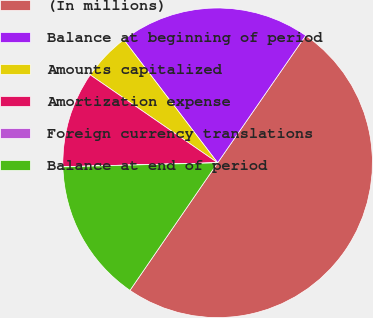Convert chart. <chart><loc_0><loc_0><loc_500><loc_500><pie_chart><fcel>(In millions)<fcel>Balance at beginning of period<fcel>Amounts capitalized<fcel>Amortization expense<fcel>Foreign currency translations<fcel>Balance at end of period<nl><fcel>49.95%<fcel>20.0%<fcel>5.02%<fcel>10.01%<fcel>0.02%<fcel>15.0%<nl></chart> 